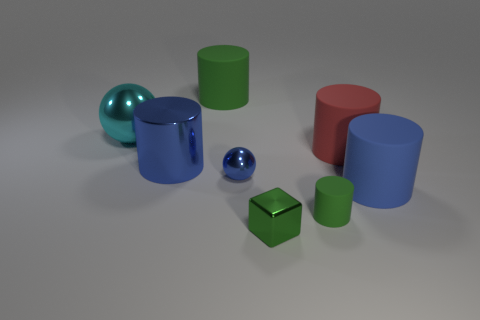What number of other things are there of the same color as the tiny cylinder?
Your answer should be very brief. 2. Is the number of shiny cylinders behind the big cyan ball less than the number of tiny cyan metallic blocks?
Provide a short and direct response. No. There is a green rubber thing that is in front of the big shiny cylinder; what shape is it?
Offer a very short reply. Cylinder. There is a red object; does it have the same size as the ball that is right of the big cyan shiny sphere?
Offer a very short reply. No. Are there any big blue things that have the same material as the tiny green block?
Offer a terse response. Yes. What number of balls are either metallic things or small purple matte objects?
Ensure brevity in your answer.  2. Is there a blue metallic object behind the big blue cylinder left of the green metal thing?
Offer a very short reply. No. Is the number of tiny green matte objects less than the number of big blue cylinders?
Provide a short and direct response. Yes. What number of small blue things have the same shape as the small green rubber object?
Provide a short and direct response. 0. What number of green things are either cubes or large metal balls?
Provide a short and direct response. 1. 